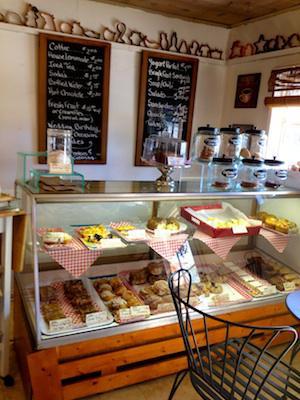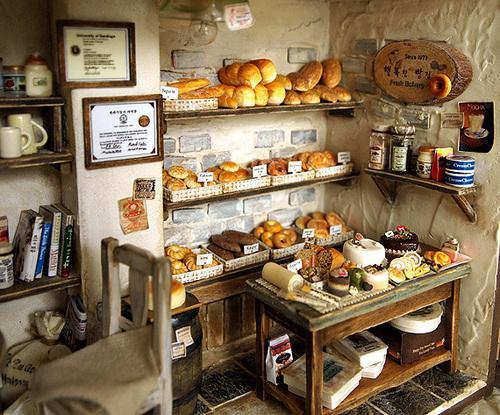The first image is the image on the left, the second image is the image on the right. Given the left and right images, does the statement "In one image, dark wall-mounted menu boards have items listed in white writing." hold true? Answer yes or no. Yes. 